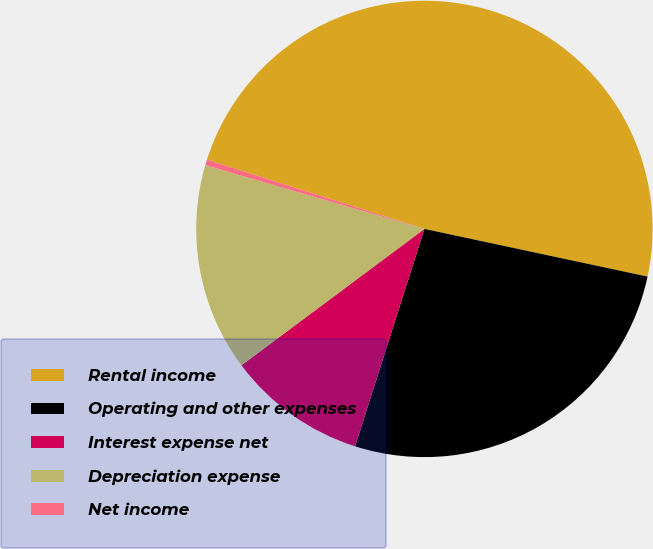<chart> <loc_0><loc_0><loc_500><loc_500><pie_chart><fcel>Rental income<fcel>Operating and other expenses<fcel>Interest expense net<fcel>Depreciation expense<fcel>Net income<nl><fcel>48.44%<fcel>26.56%<fcel>9.89%<fcel>14.7%<fcel>0.4%<nl></chart> 